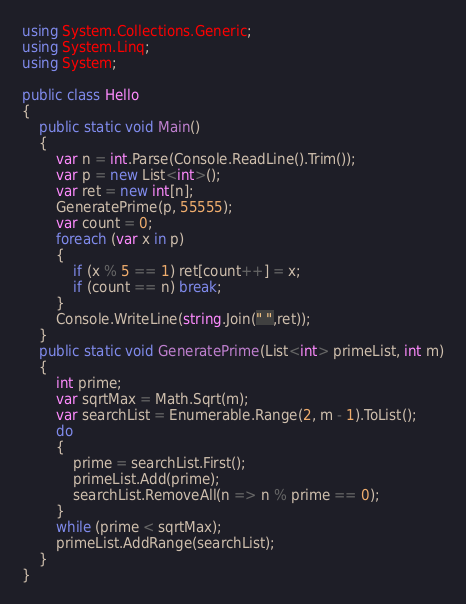Convert code to text. <code><loc_0><loc_0><loc_500><loc_500><_C#_>using System.Collections.Generic;
using System.Linq;
using System;

public class Hello
{
    public static void Main()
    {
        var n = int.Parse(Console.ReadLine().Trim());
        var p = new List<int>();
        var ret = new int[n];
        GeneratePrime(p, 55555);
        var count = 0;
        foreach (var x in p)
        {
            if (x % 5 == 1) ret[count++] = x;
            if (count == n) break;
        }
        Console.WriteLine(string.Join(" ",ret));
    }
    public static void GeneratePrime(List<int> primeList, int m)
    {
        int prime;
        var sqrtMax = Math.Sqrt(m);
        var searchList = Enumerable.Range(2, m - 1).ToList();
        do
        {
            prime = searchList.First();
            primeList.Add(prime);
            searchList.RemoveAll(n => n % prime == 0);
        }
        while (prime < sqrtMax);
        primeList.AddRange(searchList);
    }
}
</code> 